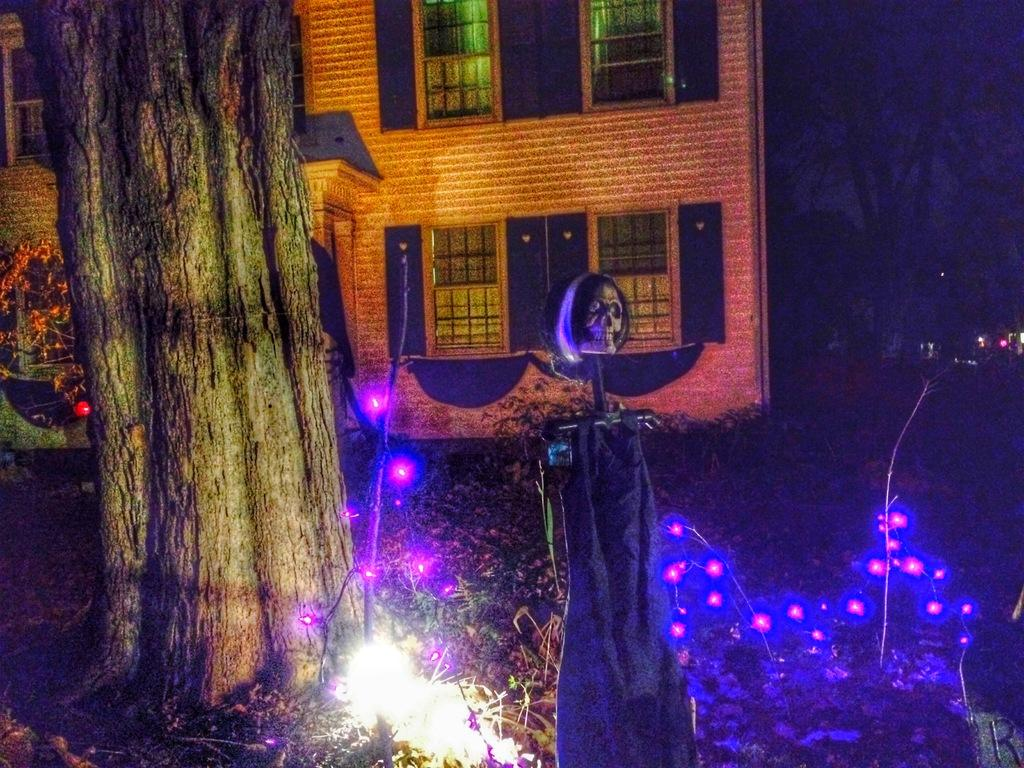What can be found at the bottom of the picture? There are lights in the bottom of the picture. What is located on the left side of the picture? There is a tree on the left side of the picture. What is visible in the background of the picture? There is a building in the background of the picture. What type of jewel is hanging from the tree in the image? There is no jewel present in the image; it features lights, a tree, and a building. Can you tell me how many times mom appears in the image? There is no person, including a mom, present in the image. 